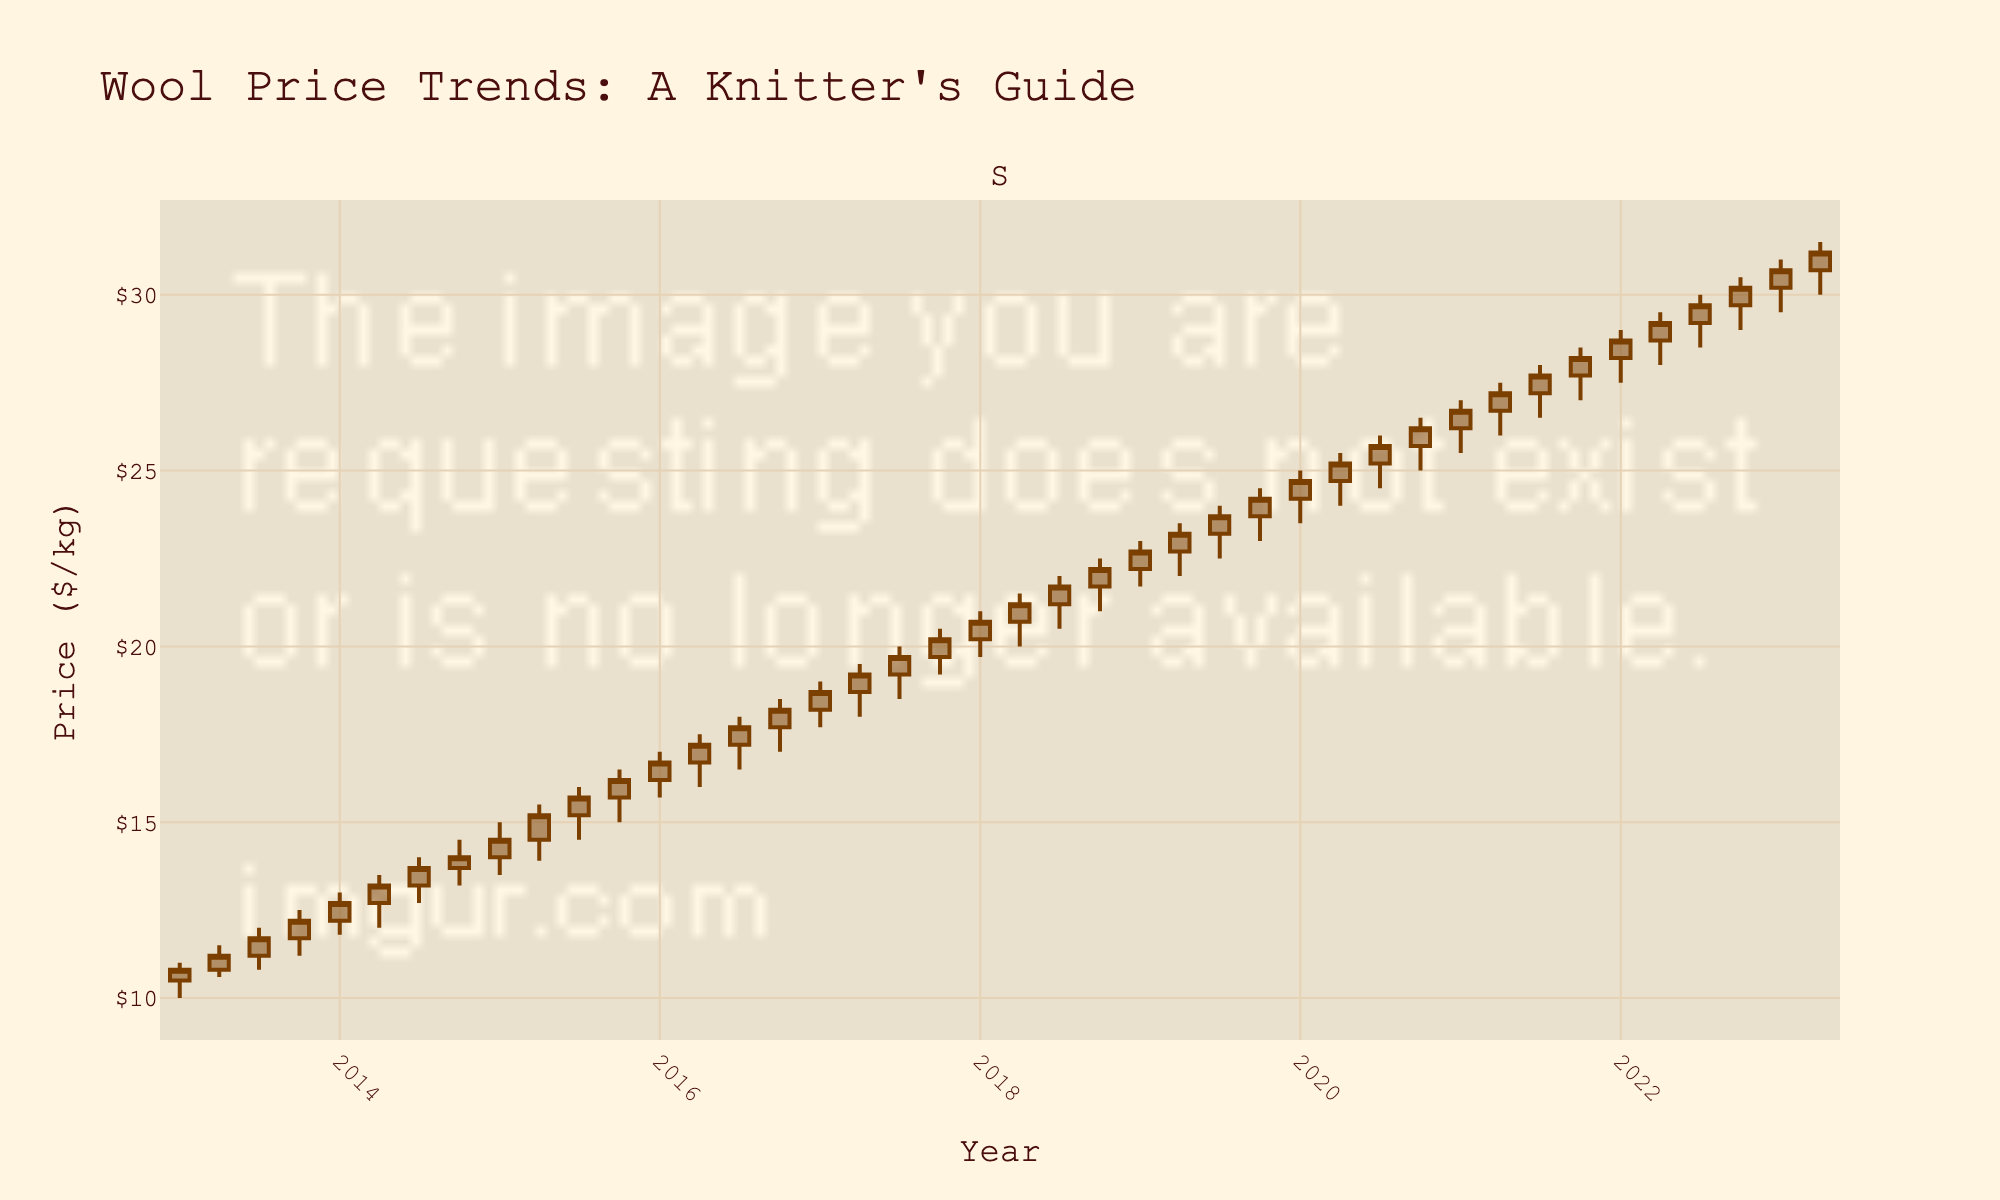What's the title of the figure? The title is located at the top of the figure. It provides an overview of what the graph represents.
Answer: Wool Price Trends: A Knitter's Guide Which year saw the highest wool price in October? To find the highest wool price in October, look at the high values for October data points across all years.
Answer: 2022 How did the wool price change from January 2015 to April 2015? Compare the closing price in January 2015 with the closing price in April 2015 to determine the change.
Answer: Increased by $0.70 What was the widest price range in any given quarter within the last decade? The widest price range is found by identifying the maximum difference between high and low prices within any quarter. Looking at all quarters, the highest range is from October 2022.
Answer: $1.50 Is there a general upward or downward trend in wool prices over the decade? By observing the overall trend of the data points from 2013 to 2023, one can identify if the prices are generally increasing or decreasing.
Answer: Upward trend In which quarter did the wool price hit its lowest value in the decade? To find the lowest value, check the low prices for all quarters and identify the minimum. The lowest value is in January 2013.
Answer: $10.00 Between 2018 and 2020, by roughly how much did wool prices increase? Compare the closing price in January 2018 with the closing price in January 2020.
Answer: $4.50 What is the general trend of wool prices in the April quarters across the decade? Look at the closing prices for all the April quarters from 2013 to 2023.
Answer: Increasing trend How does the wool price in January 2023 compare to January 2013? Compare the closing prices of both January 2013 and January 2023.
Answer: Increased by $19.90 Which quarter appears to have the most price volatility? Price volatility can be assessed by the difference between the high and low prices in each quarter. October 2022 has the most volatility.
Answer: October 2022 